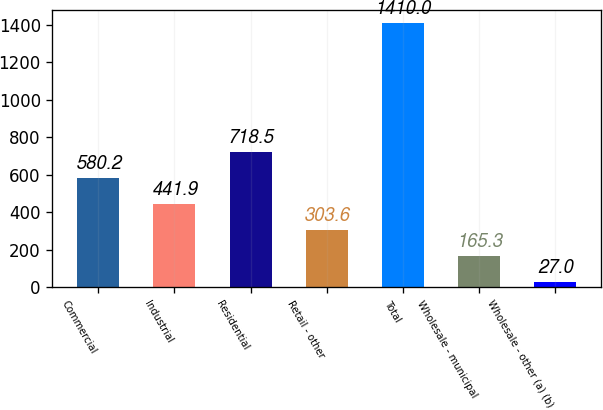Convert chart to OTSL. <chart><loc_0><loc_0><loc_500><loc_500><bar_chart><fcel>Commercial<fcel>Industrial<fcel>Residential<fcel>Retail - other<fcel>Total<fcel>Wholesale - municipal<fcel>Wholesale - other (a) (b)<nl><fcel>580.2<fcel>441.9<fcel>718.5<fcel>303.6<fcel>1410<fcel>165.3<fcel>27<nl></chart> 